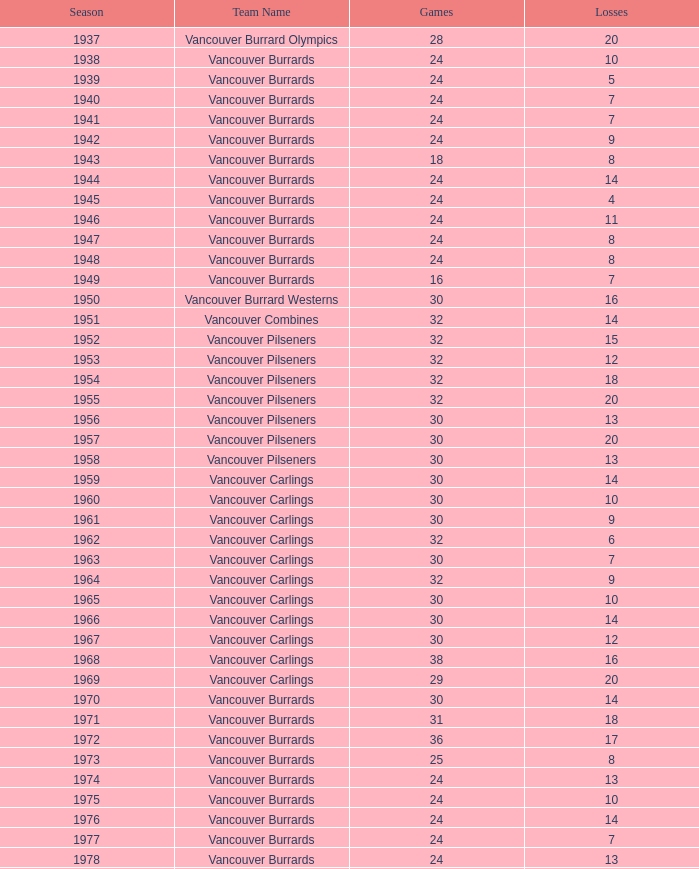What's the least amount of points for the vancouver burrards with fewer than 8 setbacks and under 24 contests? 18.0. 